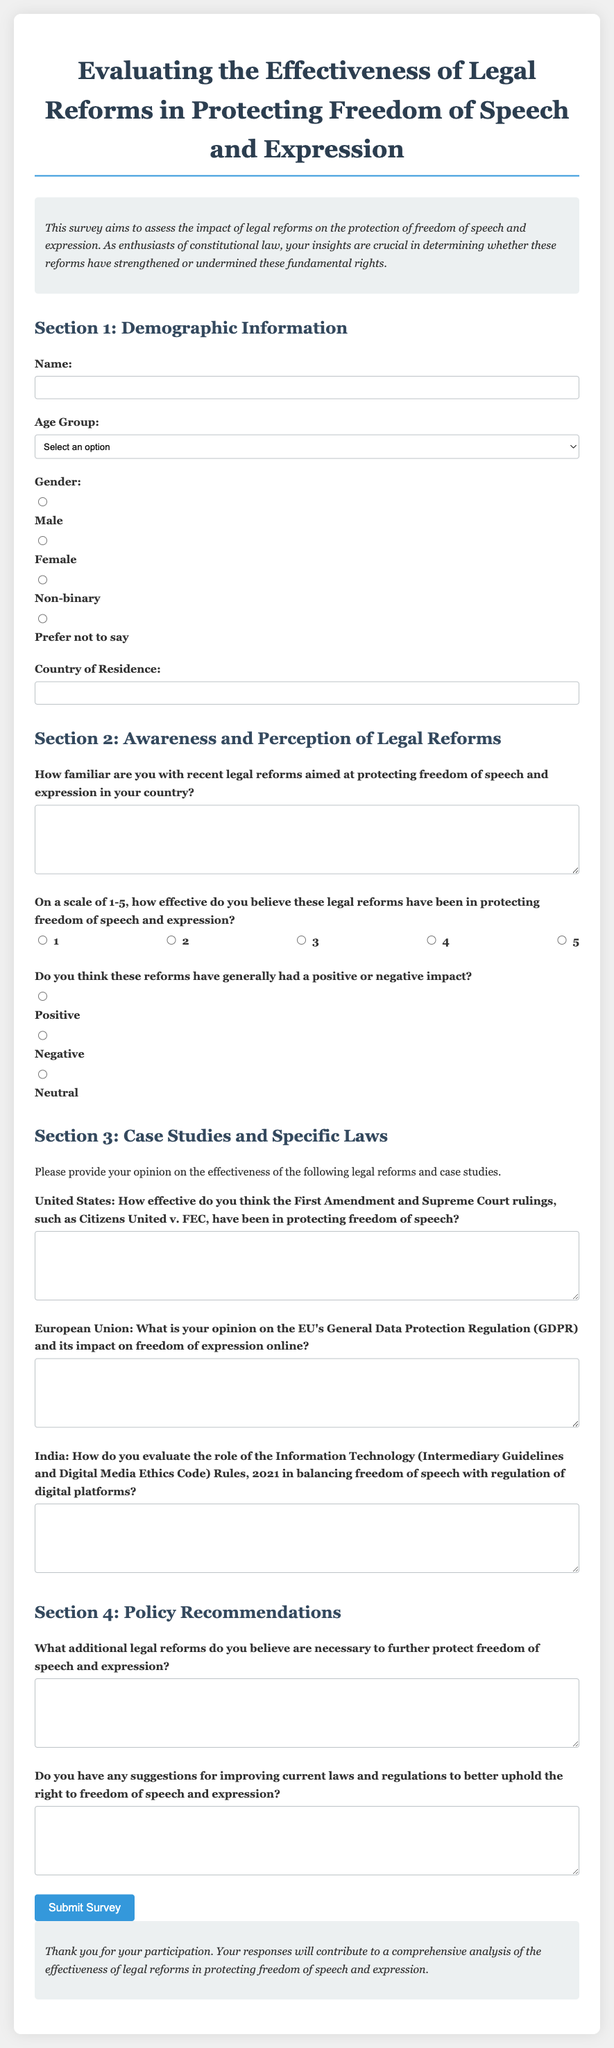What is the title of the survey? The title of the survey is found at the top of the document, which states the purpose of the survey.
Answer: Evaluating the Effectiveness of Legal Reforms in Protecting Freedom of Speech and Expression What is the required age group option for the survey? The survey contains a dropdown with various age group options for respondents to choose from.
Answer: 18-25 Which section asks about the effectiveness of legal reforms? This section directly deals with the respondent's opinions and ratings regarding recent legal reforms.
Answer: Section 2: Awareness and Perception of Legal Reforms What legal reform is mentioned in relation to the United States? This legal reform is specifically noted in the context of evaluating its effectiveness on freedom of speech.
Answer: First Amendment and Supreme Court rulings, such as Citizens United v. FEC How many questions are present in Section 4? By counting the questions listed within Section 4, we find the total.
Answer: 2 What is a suggested additional topic for the survey? The survey invites respondents to suggest reforms for further protection of specific rights.
Answer: Additional legal reforms necessary to further protect freedom of speech and expression What scale is used to measure effectiveness in the survey? The survey specifies a numeric scale for respondents to rate the effectiveness of the reforms.
Answer: 1-5 What is the purpose of this survey as stated in the introduction? The purpose summarizes the goals of the survey related to individuals' insights on legal reforms.
Answer: To assess the impact of legal reforms on the protection of freedom of speech and expression 